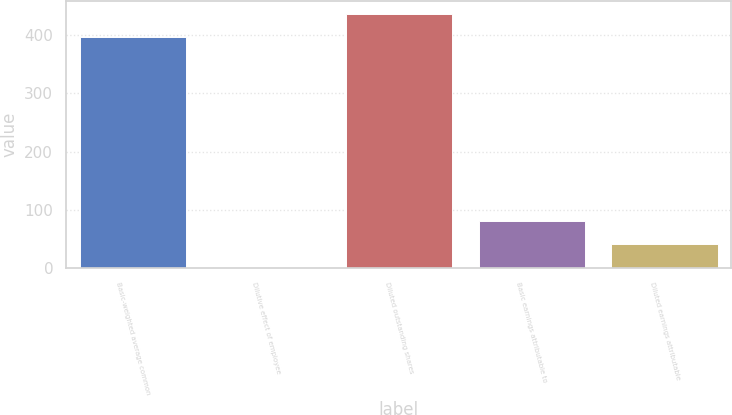<chart> <loc_0><loc_0><loc_500><loc_500><bar_chart><fcel>Basic-weighted average common<fcel>Dilutive effect of employee<fcel>Diluted outstanding shares<fcel>Basic earnings attributable to<fcel>Diluted earnings attributable<nl><fcel>397<fcel>2<fcel>436.7<fcel>81.4<fcel>41.7<nl></chart> 